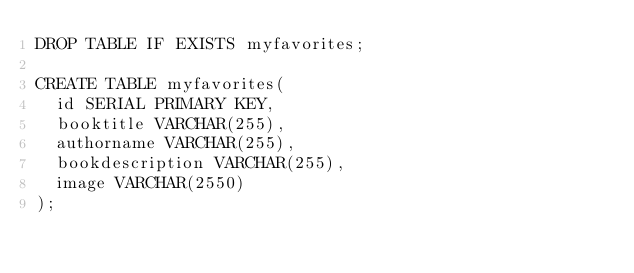<code> <loc_0><loc_0><loc_500><loc_500><_SQL_>DROP TABLE IF EXISTS myfavorites;

CREATE TABLE myfavorites(
  id SERIAL PRIMARY KEY,
  booktitle VARCHAR(255),
  authorname VARCHAR(255),
  bookdescription VARCHAR(255),
  image VARCHAR(2550)
);</code> 